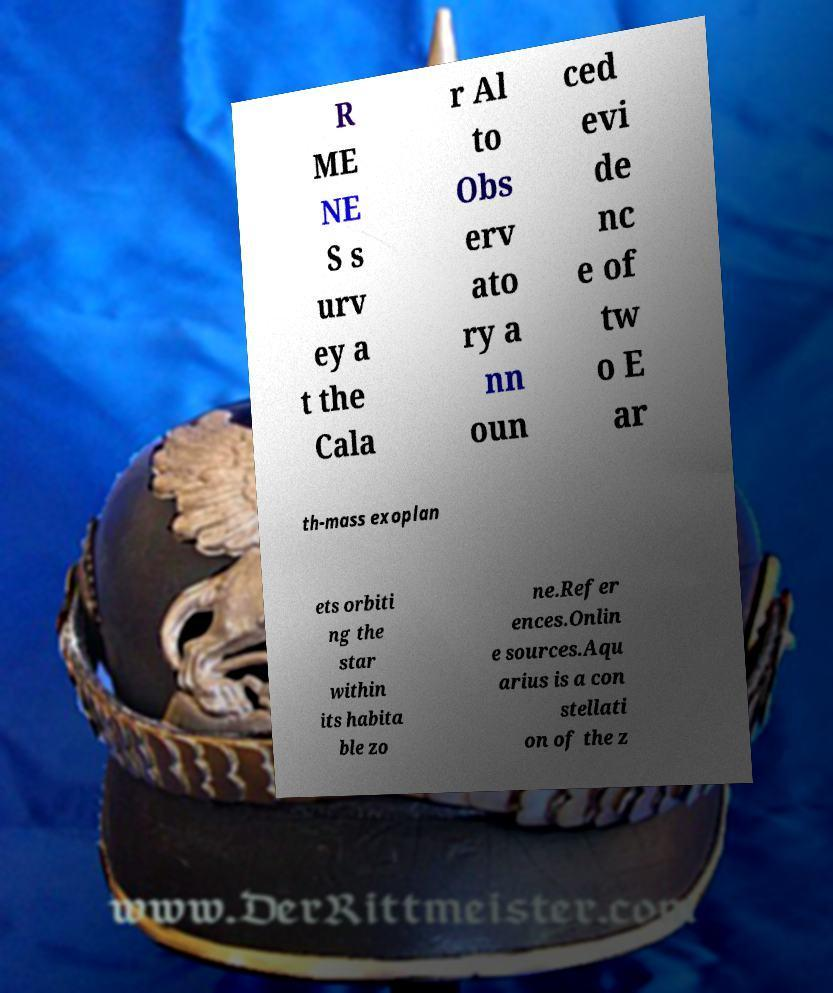Can you accurately transcribe the text from the provided image for me? R ME NE S s urv ey a t the Cala r Al to Obs erv ato ry a nn oun ced evi de nc e of tw o E ar th-mass exoplan ets orbiti ng the star within its habita ble zo ne.Refer ences.Onlin e sources.Aqu arius is a con stellati on of the z 